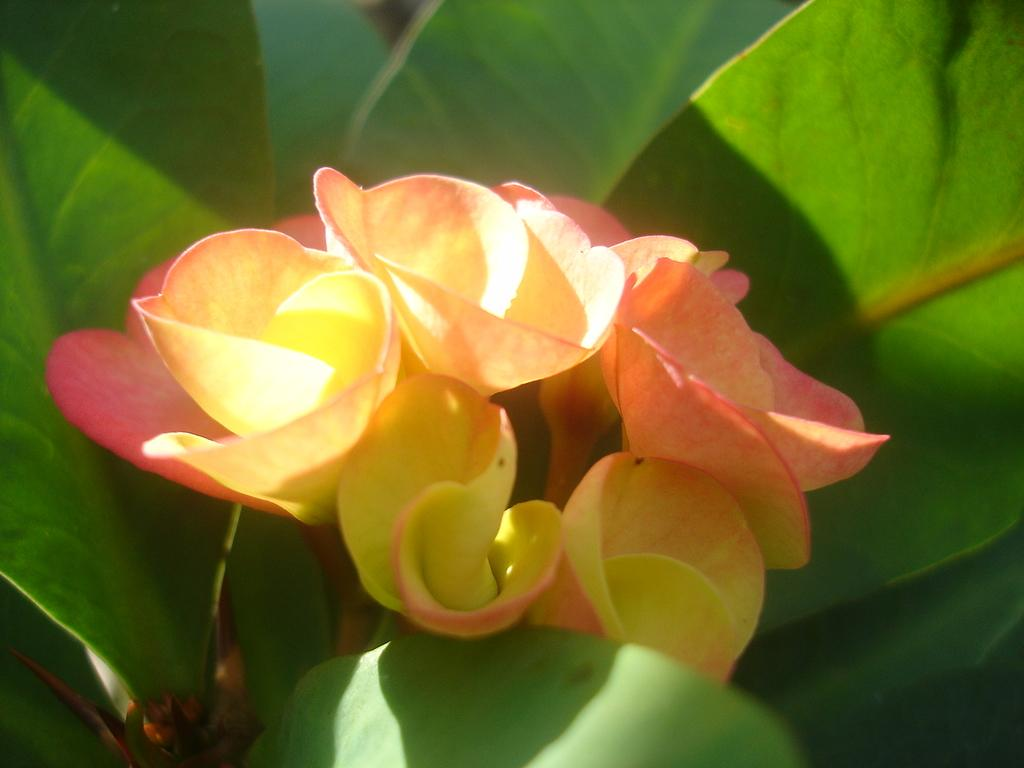What type of living organisms can be seen in the image? Flowers and plants are visible in the image. Can you describe the plants in the image? The plants in the image are not specified, but they are present alongside the flowers. What color is the blood on the volleyball in the image? There is no blood or volleyball present in the image; it only features flowers and plants. 